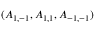<formula> <loc_0><loc_0><loc_500><loc_500>( A _ { 1 , - 1 } , A _ { 1 , 1 } , A _ { - 1 , - 1 } )</formula> 